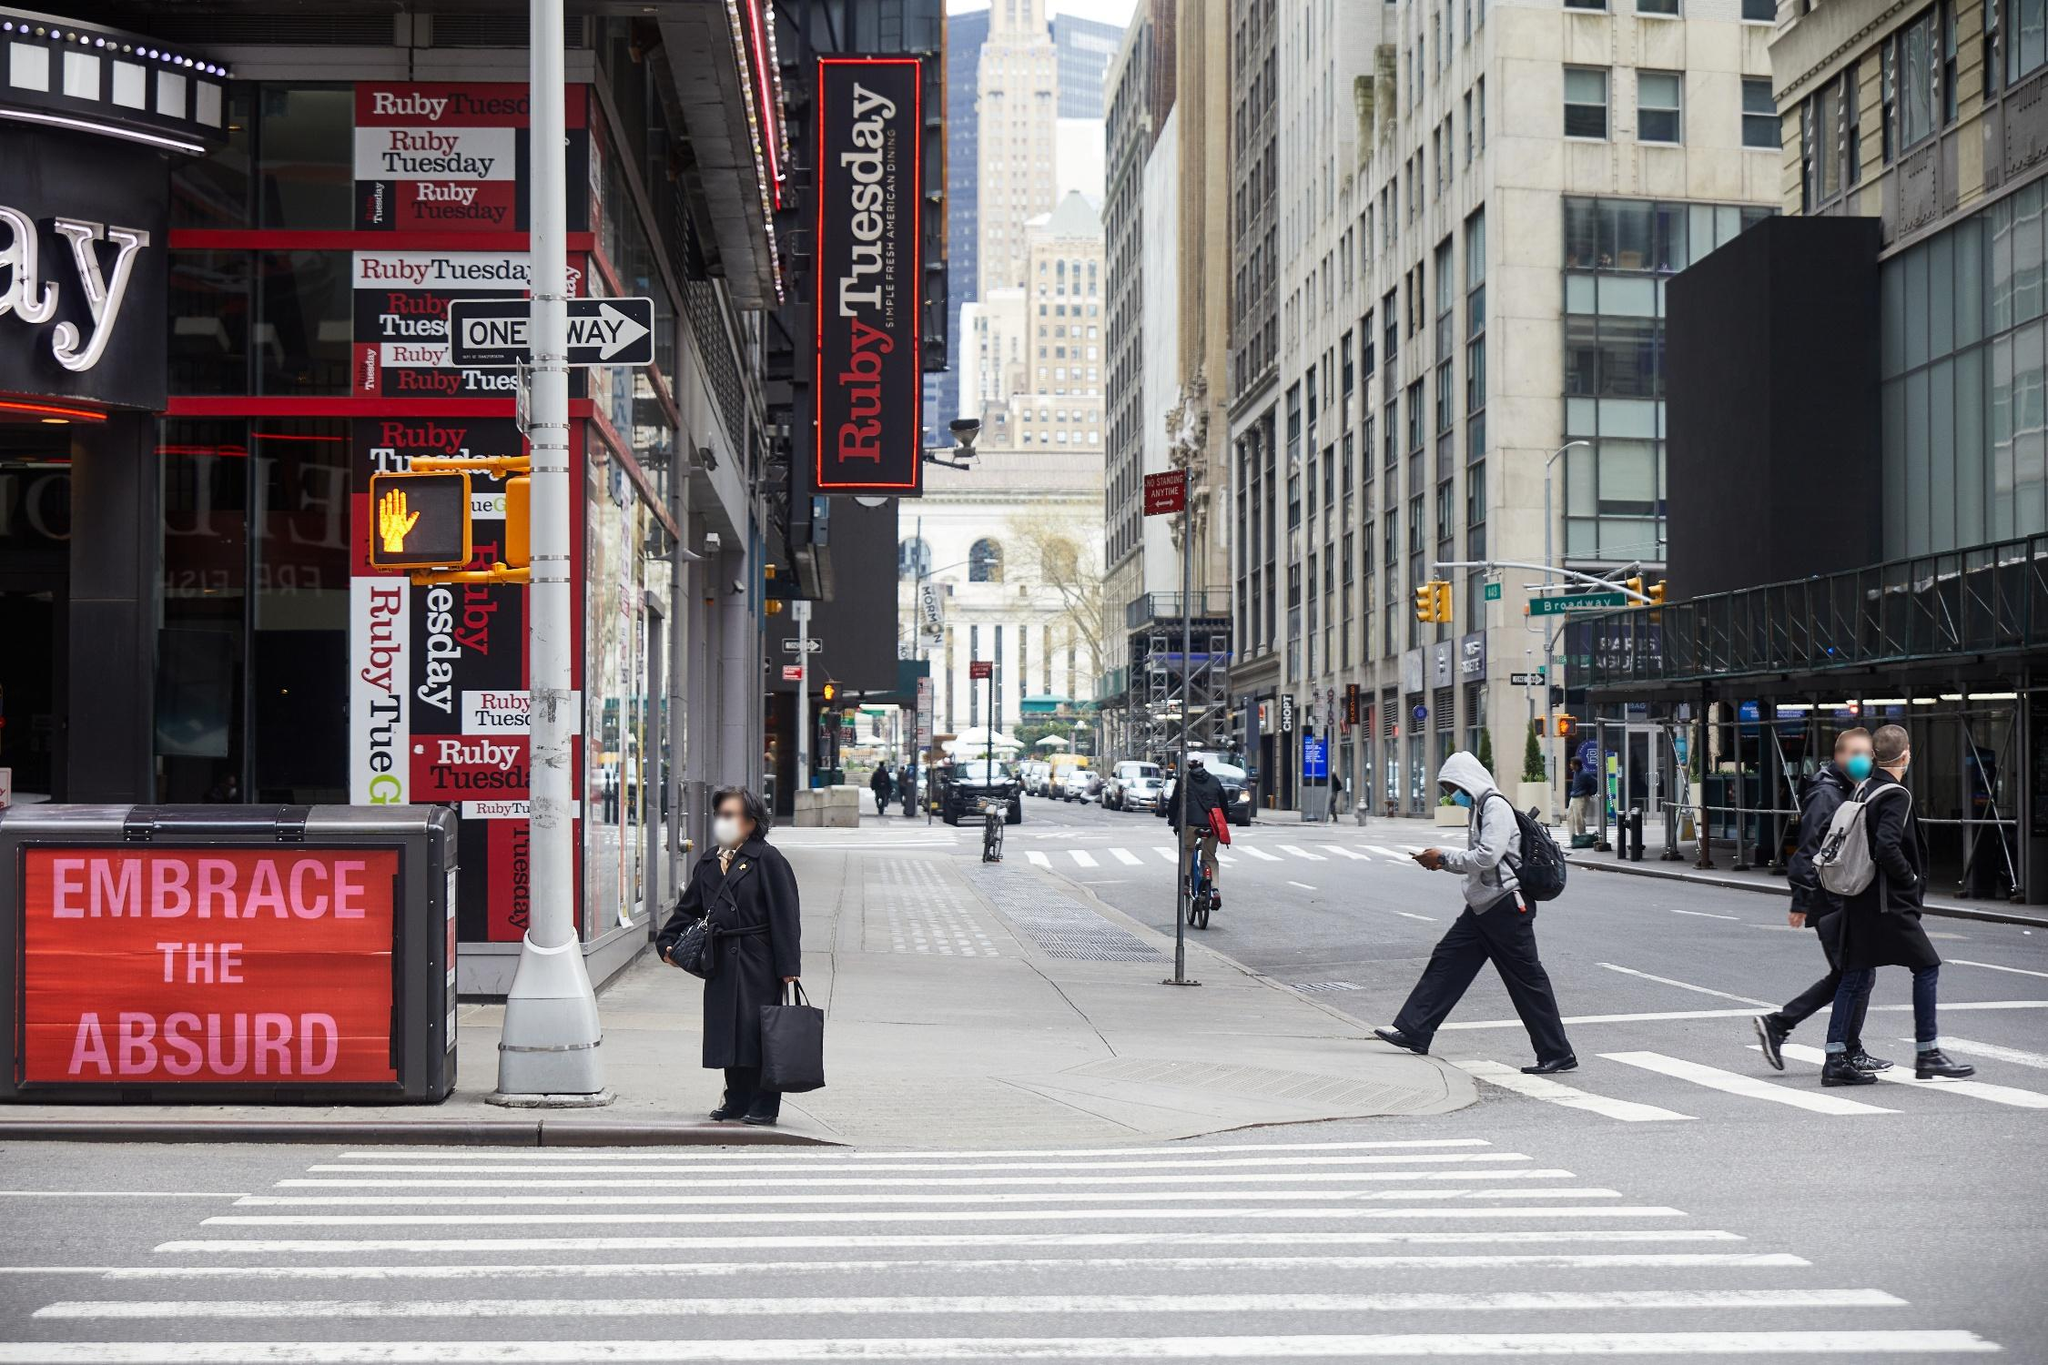Imagine a story happening around this scene. As the city buzzes around her, Jane stands at the corner, gripping her bag tightly. She’s waiting for the traffic light to change, lost in deep thought. It’s the day of her big presentation at a nearby law firm, and she’s mentally rehearsing every point. The Ruby Tuesday sign flickers in the corner of her vision, reminding her of the celebratory dinner she has planned with her friends for the evening. Suddenly, she spots a familiar figure amongst the throng of people - her old college friend, Mark, crossing the street. They haven't seen each other in years. Jane waves frantically, trying to get his attention, completely forgetting the stern expressions of punctual New Yorkers rushing past her. Can you create an imaginative story where this scene is a part of an alien invasion narrative? In an alternate reality, an ordinary day in New York City suddenly turns extraordinary. The overcast sky begins to swirl with unusual colors - hues of violet and green that capture the attention of everyone on the street. People begin to stop in their tracks, looking up with a mixture of awe and fear. In the midst of this cosmic anomaly, a soft hum resonates through the air. The Ruby Tuesday sign flickers and then shuts off. Jane, standing at the corner, notices her reflection in the building’s glass tremble slightly. Suddenly, beams of light shoot down from the sky, and large, ethereal shapes begin to materialize above the skyscrapers. The iconic New York Public Library turns its lights off, and the street is bathed in an eerie glow. It’s clear - this is the beginning of an alien invasion. But amidst the chaos, Jane spots a glimmer of hope in her old college friend Mark, whose eyes reflect determination. They know they must find a way to understand these beings and negotiate peace before it’s too late. 